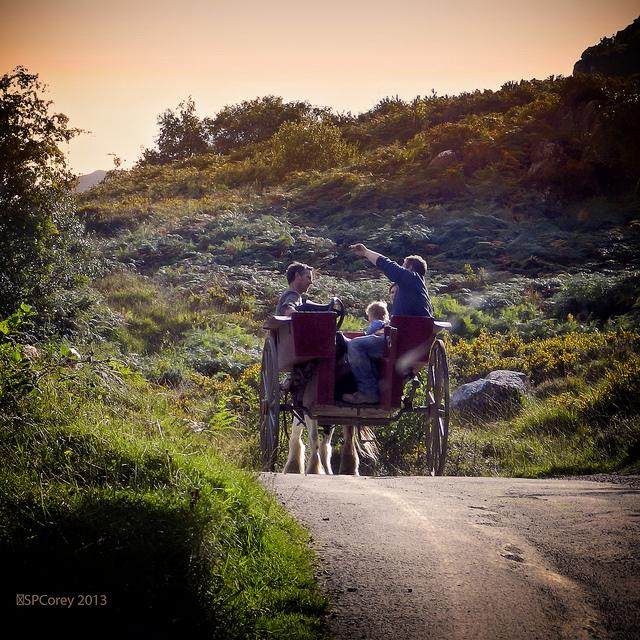Is this a family?
Short answer required. Yes. What activity is taking place?
Answer briefly. Carriage riding. Is the guy riding an elephant?
Give a very brief answer. No. Is there horses here?
Short answer required. Yes. Are the people riding a buggy?
Write a very short answer. Yes. 